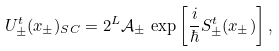Convert formula to latex. <formula><loc_0><loc_0><loc_500><loc_500>U _ { \pm } ^ { t } ( x _ { \pm } ) _ { S C } = 2 ^ { L } \mathcal { A } _ { \pm } \, \exp \left [ \frac { i } \hbar { S } _ { \pm } ^ { t } ( x _ { \pm } ) \right ] ,</formula> 